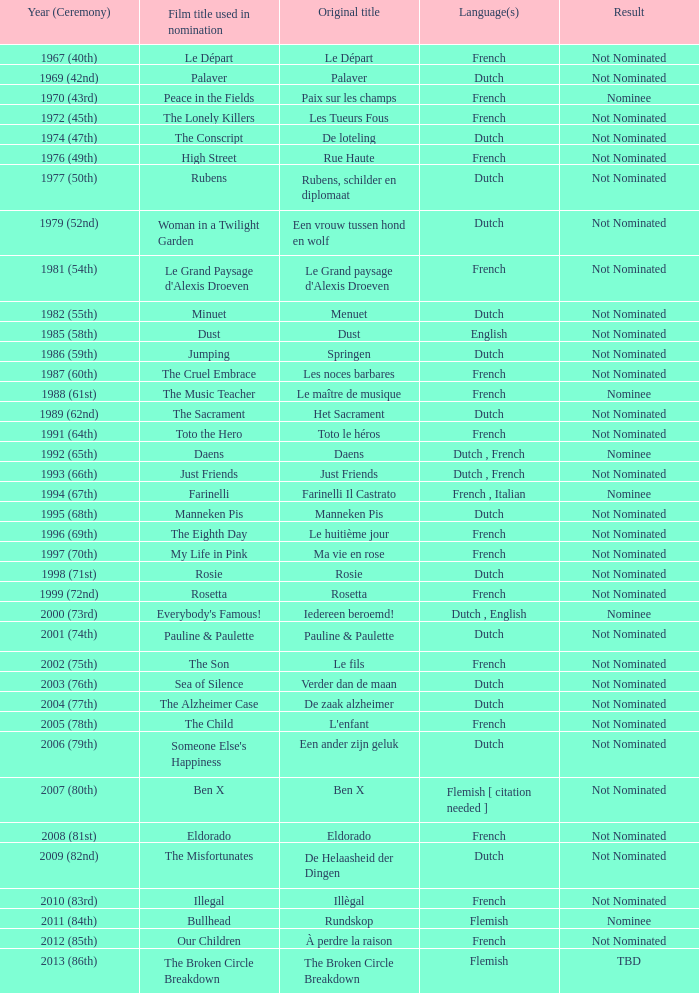What was the dutch language-nominated film called "rosie" known as? Rosie. Parse the table in full. {'header': ['Year (Ceremony)', 'Film title used in nomination', 'Original title', 'Language(s)', 'Result'], 'rows': [['1967 (40th)', 'Le Départ', 'Le Départ', 'French', 'Not Nominated'], ['1969 (42nd)', 'Palaver', 'Palaver', 'Dutch', 'Not Nominated'], ['1970 (43rd)', 'Peace in the Fields', 'Paix sur les champs', 'French', 'Nominee'], ['1972 (45th)', 'The Lonely Killers', 'Les Tueurs Fous', 'French', 'Not Nominated'], ['1974 (47th)', 'The Conscript', 'De loteling', 'Dutch', 'Not Nominated'], ['1976 (49th)', 'High Street', 'Rue Haute', 'French', 'Not Nominated'], ['1977 (50th)', 'Rubens', 'Rubens, schilder en diplomaat', 'Dutch', 'Not Nominated'], ['1979 (52nd)', 'Woman in a Twilight Garden', 'Een vrouw tussen hond en wolf', 'Dutch', 'Not Nominated'], ['1981 (54th)', "Le Grand Paysage d'Alexis Droeven", "Le Grand paysage d'Alexis Droeven", 'French', 'Not Nominated'], ['1982 (55th)', 'Minuet', 'Menuet', 'Dutch', 'Not Nominated'], ['1985 (58th)', 'Dust', 'Dust', 'English', 'Not Nominated'], ['1986 (59th)', 'Jumping', 'Springen', 'Dutch', 'Not Nominated'], ['1987 (60th)', 'The Cruel Embrace', 'Les noces barbares', 'French', 'Not Nominated'], ['1988 (61st)', 'The Music Teacher', 'Le maître de musique', 'French', 'Nominee'], ['1989 (62nd)', 'The Sacrament', 'Het Sacrament', 'Dutch', 'Not Nominated'], ['1991 (64th)', 'Toto the Hero', 'Toto le héros', 'French', 'Not Nominated'], ['1992 (65th)', 'Daens', 'Daens', 'Dutch , French', 'Nominee'], ['1993 (66th)', 'Just Friends', 'Just Friends', 'Dutch , French', 'Not Nominated'], ['1994 (67th)', 'Farinelli', 'Farinelli Il Castrato', 'French , Italian', 'Nominee'], ['1995 (68th)', 'Manneken Pis', 'Manneken Pis', 'Dutch', 'Not Nominated'], ['1996 (69th)', 'The Eighth Day', 'Le huitième jour', 'French', 'Not Nominated'], ['1997 (70th)', 'My Life in Pink', 'Ma vie en rose', 'French', 'Not Nominated'], ['1998 (71st)', 'Rosie', 'Rosie', 'Dutch', 'Not Nominated'], ['1999 (72nd)', 'Rosetta', 'Rosetta', 'French', 'Not Nominated'], ['2000 (73rd)', "Everybody's Famous!", 'Iedereen beroemd!', 'Dutch , English', 'Nominee'], ['2001 (74th)', 'Pauline & Paulette', 'Pauline & Paulette', 'Dutch', 'Not Nominated'], ['2002 (75th)', 'The Son', 'Le fils', 'French', 'Not Nominated'], ['2003 (76th)', 'Sea of Silence', 'Verder dan de maan', 'Dutch', 'Not Nominated'], ['2004 (77th)', 'The Alzheimer Case', 'De zaak alzheimer', 'Dutch', 'Not Nominated'], ['2005 (78th)', 'The Child', "L'enfant", 'French', 'Not Nominated'], ['2006 (79th)', "Someone Else's Happiness", 'Een ander zijn geluk', 'Dutch', 'Not Nominated'], ['2007 (80th)', 'Ben X', 'Ben X', 'Flemish [ citation needed ]', 'Not Nominated'], ['2008 (81st)', 'Eldorado', 'Eldorado', 'French', 'Not Nominated'], ['2009 (82nd)', 'The Misfortunates', 'De Helaasheid der Dingen', 'Dutch', 'Not Nominated'], ['2010 (83rd)', 'Illegal', 'Illègal', 'French', 'Not Nominated'], ['2011 (84th)', 'Bullhead', 'Rundskop', 'Flemish', 'Nominee'], ['2012 (85th)', 'Our Children', 'À perdre la raison', 'French', 'Not Nominated'], ['2013 (86th)', 'The Broken Circle Breakdown', 'The Broken Circle Breakdown', 'Flemish', 'TBD']]} 